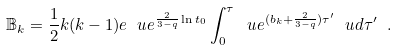Convert formula to latex. <formula><loc_0><loc_0><loc_500><loc_500>\mathbb { B } _ { k } = \frac { 1 } { 2 } k ( k - 1 ) e \ u e ^ { \frac { 2 } { 3 - q } \ln t _ { 0 } } \int _ { 0 } ^ { \tau } \ u e ^ { ( b _ { k } + \frac { 2 } { 3 - q } ) \tau ^ { \prime } } \ u d \tau ^ { \prime } \ .</formula> 